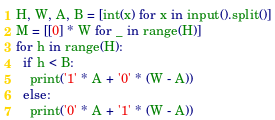Convert code to text. <code><loc_0><loc_0><loc_500><loc_500><_Python_>H, W, A, B = [int(x) for x in input().split()]
M = [[0] * W for _ in range(H)]
for h in range(H):
  if h < B:
    print('1' * A + '0' * (W - A))
  else:
    print('0' * A + '1' * (W - A))
</code> 